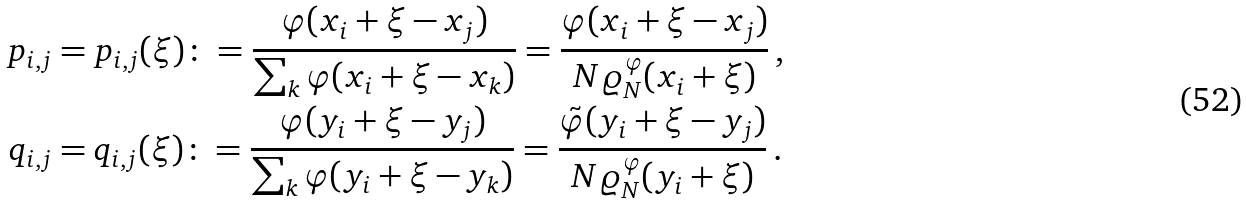<formula> <loc_0><loc_0><loc_500><loc_500>p _ { i , j } & = p _ { i , j } ( \xi ) \colon = \frac { \varphi ( x _ { i } + \xi - x _ { j } ) } { \sum _ { k } \varphi ( x _ { i } + \xi - x _ { k } ) } = \frac { \varphi ( x _ { i } + \xi - x _ { j } ) } { N \varrho _ { N } ^ { \varphi } ( x _ { i } + \xi ) } \, , \\ q _ { i , j } & = q _ { i , j } ( \xi ) \colon = \frac { \varphi ( y _ { i } + \xi - y _ { j } ) } { \sum _ { k } \varphi ( y _ { i } + \xi - y _ { k } ) } = \frac { \tilde { \varphi } ( y _ { i } + \xi - y _ { j } ) } { N \varrho _ { N } ^ { \varphi } ( y _ { i } + \xi ) } \, .</formula> 